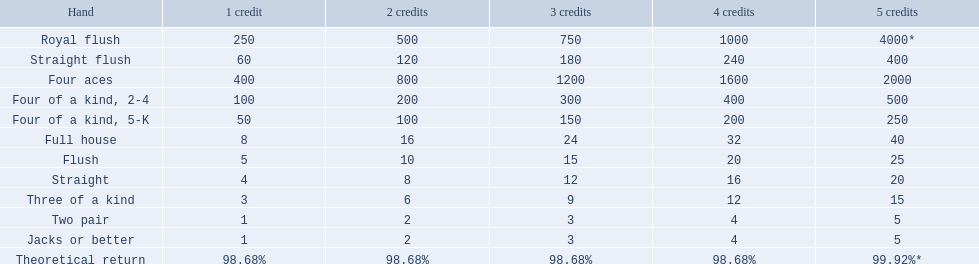What hand ranks below a straight flush? Four aces. What hand ranks below four aces? Four of a kind, 2-4. Between a straight and a flush, which hand has a higher ranking? Flush. 